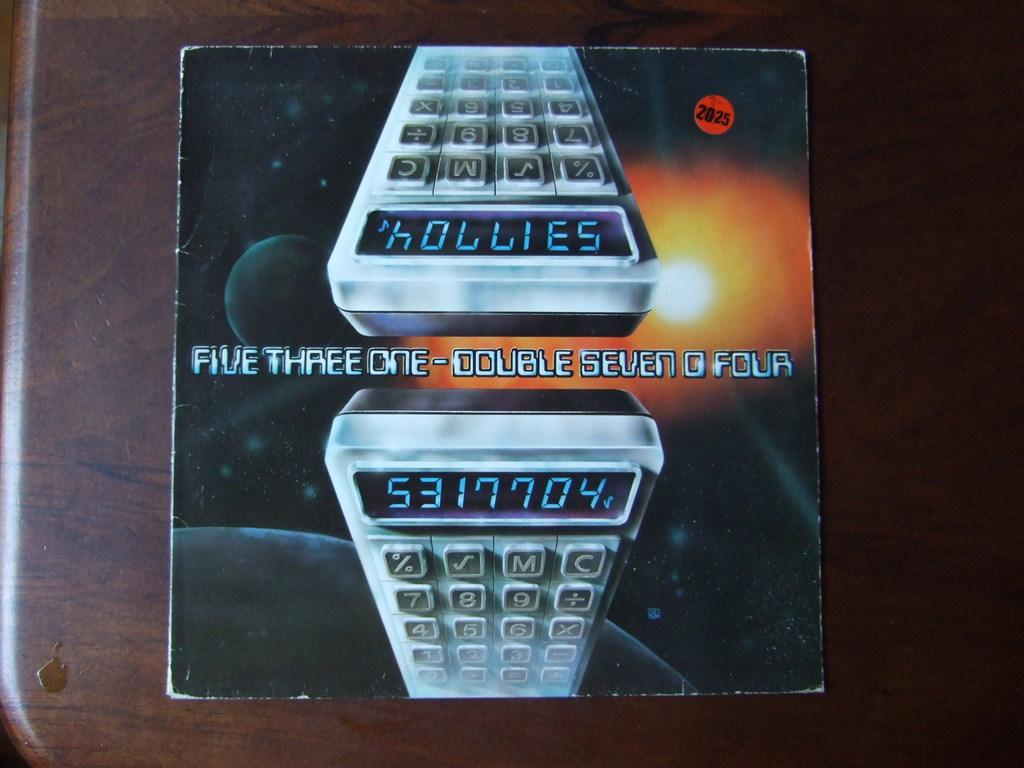<image>
Relay a brief, clear account of the picture shown. A calcular's reflection of itself on a paper with numbers 5317704 displayed on calculator. 